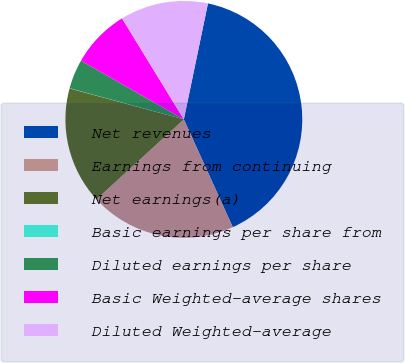<chart> <loc_0><loc_0><loc_500><loc_500><pie_chart><fcel>Net revenues<fcel>Earnings from continuing<fcel>Net earnings(a)<fcel>Basic earnings per share from<fcel>Diluted earnings per share<fcel>Basic Weighted-average shares<fcel>Diluted Weighted-average<nl><fcel>39.95%<fcel>19.99%<fcel>16.0%<fcel>0.03%<fcel>4.02%<fcel>8.01%<fcel>12.0%<nl></chart> 